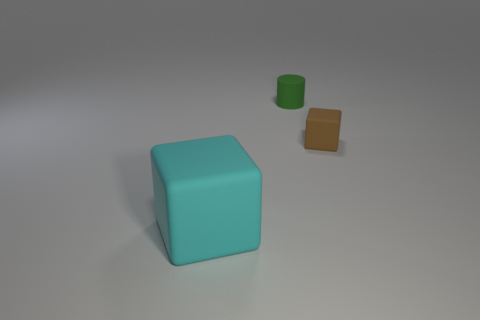Add 1 green metallic blocks. How many objects exist? 4 Subtract all cylinders. How many objects are left? 2 Subtract 0 purple cubes. How many objects are left? 3 Subtract all small objects. Subtract all small blocks. How many objects are left? 0 Add 1 small rubber blocks. How many small rubber blocks are left? 2 Add 2 big blue balls. How many big blue balls exist? 2 